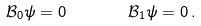Convert formula to latex. <formula><loc_0><loc_0><loc_500><loc_500>\mathcal { B } _ { 0 } \psi = 0 \quad \, \quad \mathcal { B } _ { 1 } \psi = 0 \, .</formula> 